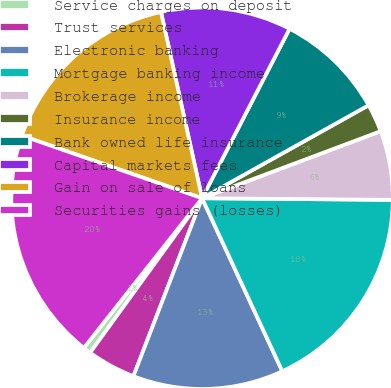<chart> <loc_0><loc_0><loc_500><loc_500><pie_chart><fcel>Service charges on deposit<fcel>Trust services<fcel>Electronic banking<fcel>Mortgage banking income<fcel>Brokerage income<fcel>Insurance income<fcel>Bank owned life insurance<fcel>Capital markets fees<fcel>Gain on sale of loans<fcel>Securities gains (losses)<nl><fcel>0.66%<fcel>4.12%<fcel>12.77%<fcel>17.95%<fcel>5.85%<fcel>2.39%<fcel>9.31%<fcel>11.04%<fcel>16.22%<fcel>19.68%<nl></chart> 